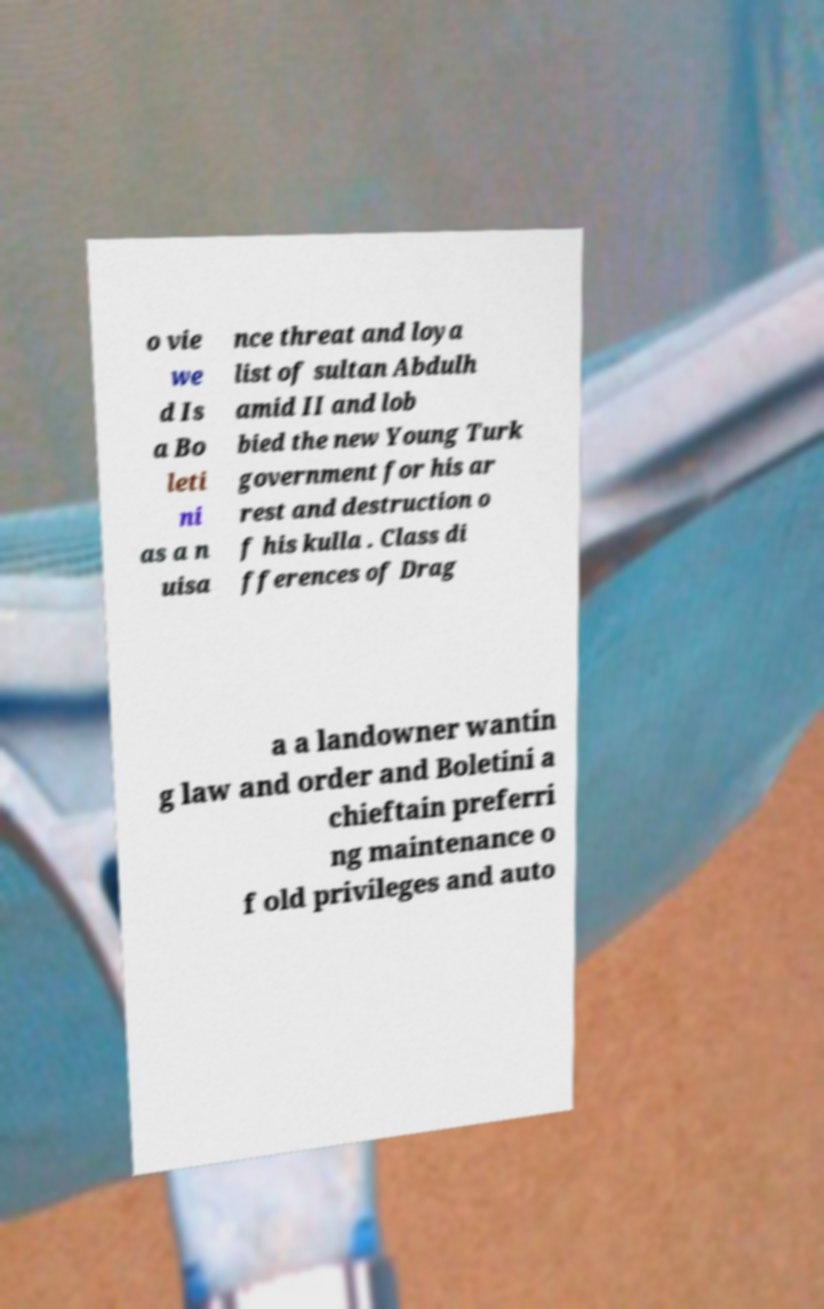There's text embedded in this image that I need extracted. Can you transcribe it verbatim? o vie we d Is a Bo leti ni as a n uisa nce threat and loya list of sultan Abdulh amid II and lob bied the new Young Turk government for his ar rest and destruction o f his kulla . Class di fferences of Drag a a landowner wantin g law and order and Boletini a chieftain preferri ng maintenance o f old privileges and auto 